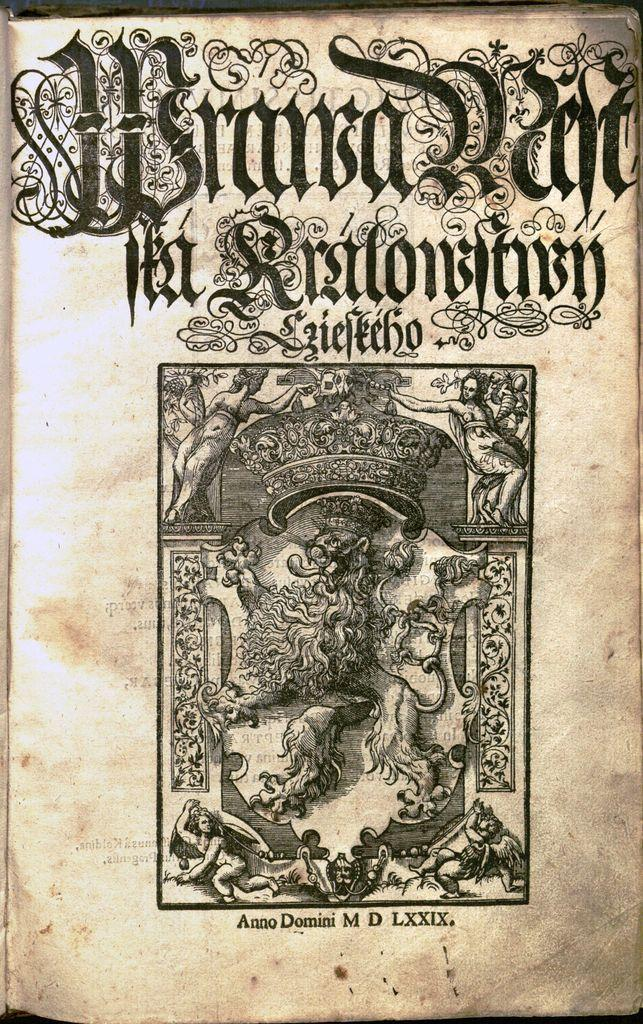<image>
Present a compact description of the photo's key features. The opening page and illustration for a book by Anno Domini MD. 